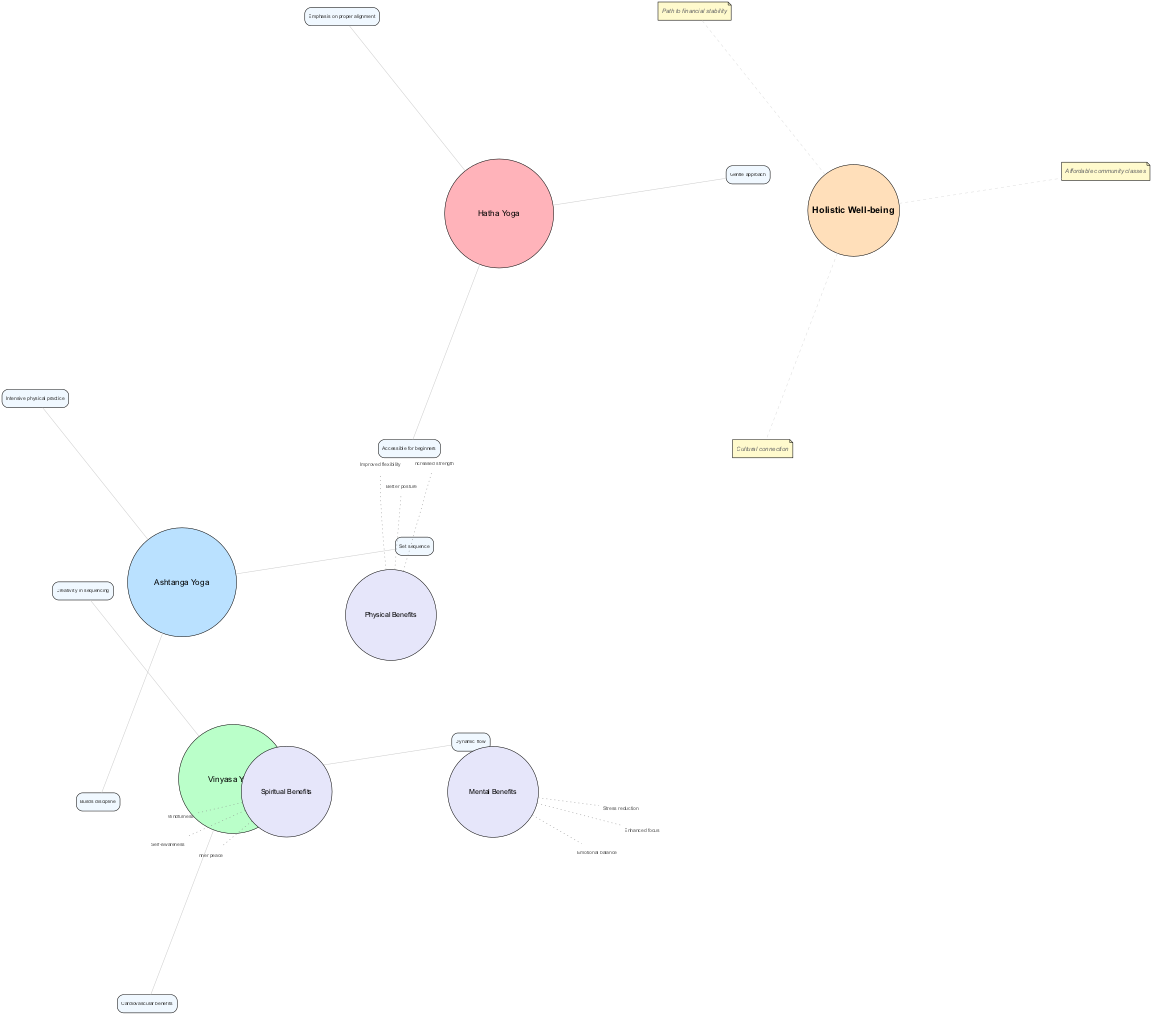What are the three main yoga styles depicted in the diagram? The diagram's main circles list "Hatha Yoga", "Vinyasa Yoga", and "Ashtanga Yoga" as the three primary styles.
Answer: Hatha Yoga, Vinyasa Yoga, Ashtanga Yoga Which unique element is associated with Vinyasa Yoga? The diagram specifies a unique element for Vinyasa Yoga as "Dynamic flow", which is listed under that style.
Answer: Dynamic flow How many elements are listed under the mental benefits overlapping area? The diagram presents three elements under mental benefits: "Stress reduction", "Enhanced focus", and "Emotional balance". Therefore, counting these gives the total as three.
Answer: 3 What is the shared benefit between all three yoga styles? The center node labeled "Holistic Well-being" signifies a benefit that encompasses all three approaches to yoga, emphasizing their collective positive impact.
Answer: Holistic Well-being What unique element indicates the beginner-friendly nature of Hatha Yoga? The diagram identifies "Accessible for beginners" as one of the unique elements associated with Hatha Yoga.
Answer: Accessible for beginners Which yoga style emphasizes discipline according to the unique elements? The unique element "Builds discipline" is specifically associated with Ashtanga Yoga, indicating its emphasis on discipline in practice.
Answer: Ashtanga Yoga What color represents Hatha Yoga in the diagram? The color associated with Hatha Yoga is #FFB3BA, which corresponds to the filled circle representing this style in the diagram.
Answer: #FFB3BA Which overlapping area addresses spiritual well-being? The diagram lists "Spiritual Benefits" as the overlapping area that focuses on aspects of spiritual well-being shared among the yoga styles.
Answer: Spiritual Benefits Which personal insight relates to financial aspects of yoga practice? The personal insight "Path to financial stability" directly points to the financial implications of engaging with yoga practices within the community context.
Answer: Path to financial stability 